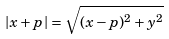Convert formula to latex. <formula><loc_0><loc_0><loc_500><loc_500>| x + p | = \sqrt { ( x - p ) ^ { 2 } + y ^ { 2 } }</formula> 